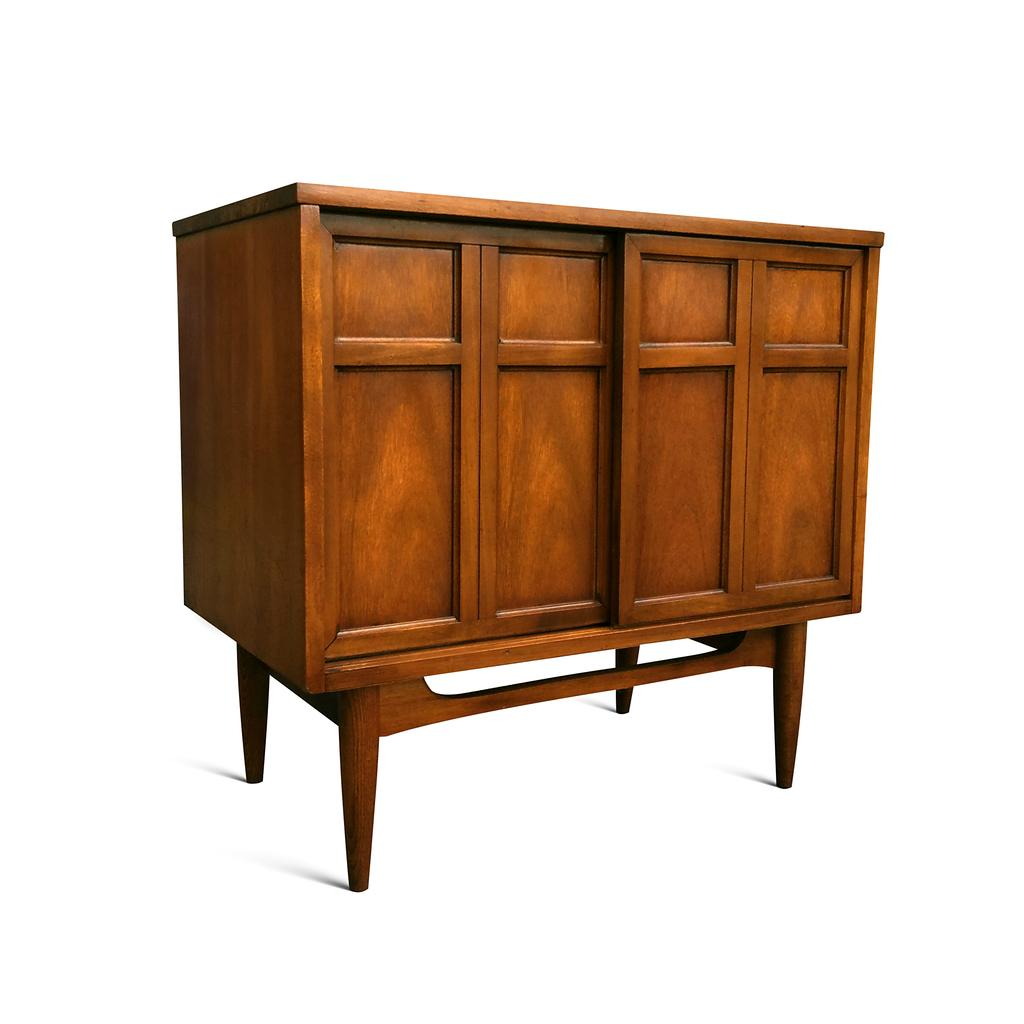What type of furniture is present in the image? There is a cupboard in the image. What color is the background of the image? The background of the image is white. Where is the mailbox located in the image? There is no mailbox present in the image. What type of sack is hanging on the cupboard in the image? There is no sack present in the image. 